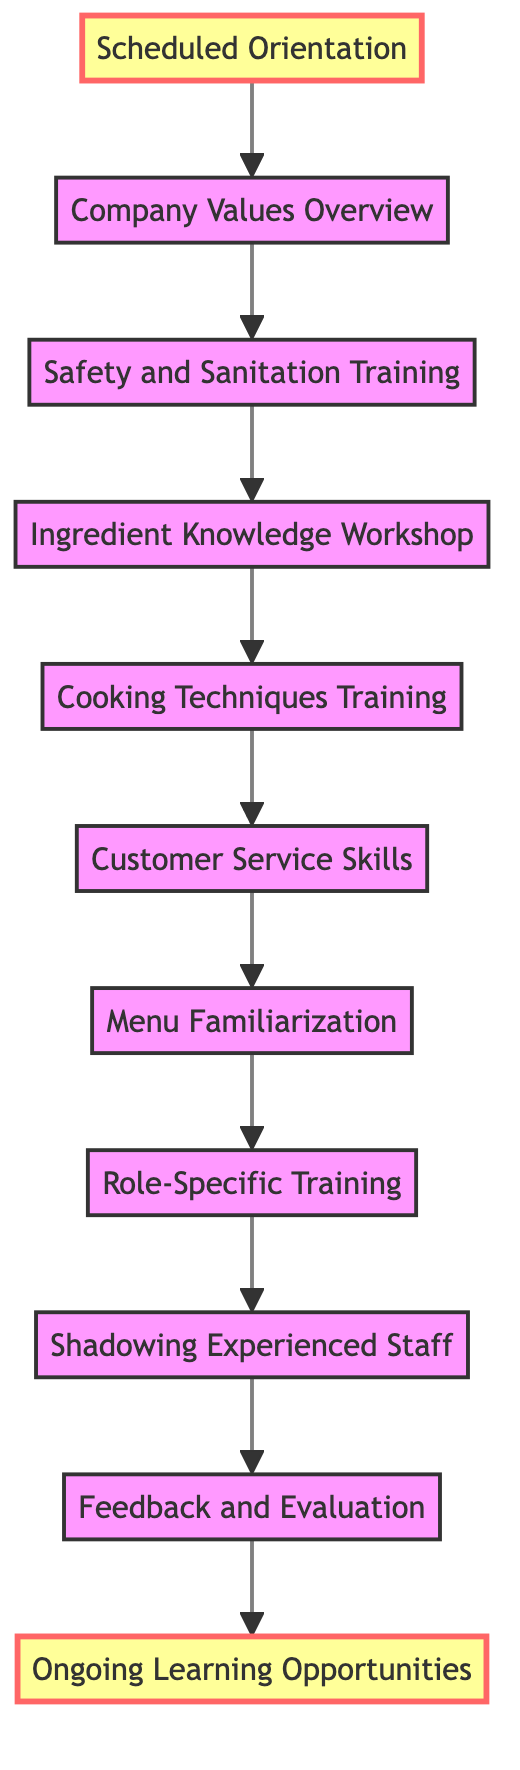What is the first step in the employee training workflow? The first node in the diagram is "Scheduled Orientation," indicating that this is the starting point of the workflow.
Answer: Scheduled Orientation How many nodes are there in the training workflow? Counting the nodes listed in the diagram, there are a total of 11 nodes representing different training steps.
Answer: 11 What is the last training step in the workflow? The final node in the sequence is "Ongoing Learning Opportunities," which signifies the end of the initial training process.
Answer: Ongoing Learning Opportunities Which node is directly connected to the "Customer Service Skills" node? By examining the diagram, "Customer Service Skills" is followed by "Menu Familiarization," indicating a direct connection in the training flow.
Answer: Menu Familiarization What is the relationship between "Safety and Sanitation Training" and "Cooking Techniques Training"? The connection shows that "Safety and Sanitation Training" leads directly into "Ingredient Knowledge Workshop," which then leads to "Cooking Techniques Training," establishing a sequence in the training process.
Answer: Sequential How many edges are there in the training workflow? Analyzing the connections between the nodes, there are a total of 10 edges that link the various training steps in the workflow.
Answer: 10 What node precedes "Shadowing Experienced Staff"? The node that directly comes before "Shadowing Experienced Staff" is "Role-Specific Training," which is a necessary step before shadowing.
Answer: Role-Specific Training What is the main purpose of the "Feedback and Evaluation" step? This step serves as a point for assessing the performance of the trainees based on their previous training steps, allowing for adjustments and improvements.
Answer: Assessment Which two nodes are highlighted in the diagram? The diagram highlights "Scheduled Orientation" and "Ongoing Learning Opportunities," indicating their importance in the workflow.
Answer: Scheduled Orientation, Ongoing Learning Opportunities 